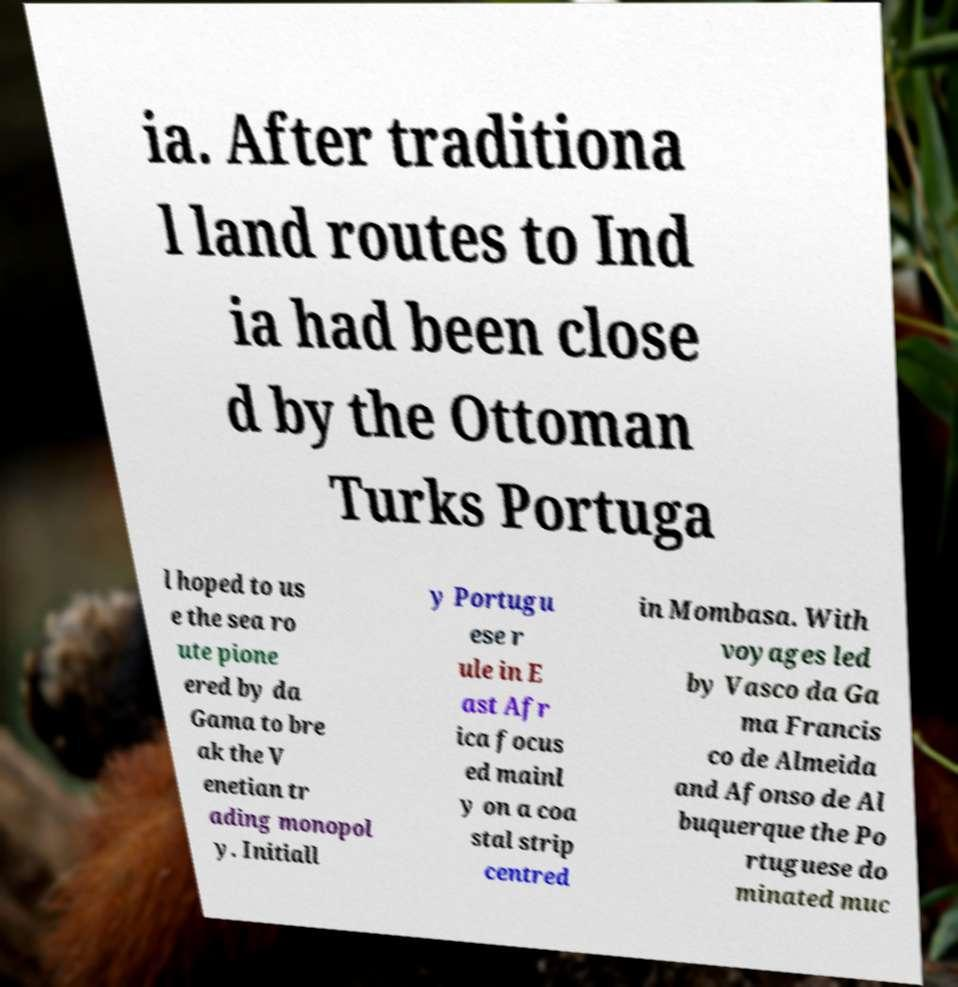For documentation purposes, I need the text within this image transcribed. Could you provide that? ia. After traditiona l land routes to Ind ia had been close d by the Ottoman Turks Portuga l hoped to us e the sea ro ute pione ered by da Gama to bre ak the V enetian tr ading monopol y. Initiall y Portugu ese r ule in E ast Afr ica focus ed mainl y on a coa stal strip centred in Mombasa. With voyages led by Vasco da Ga ma Francis co de Almeida and Afonso de Al buquerque the Po rtuguese do minated muc 